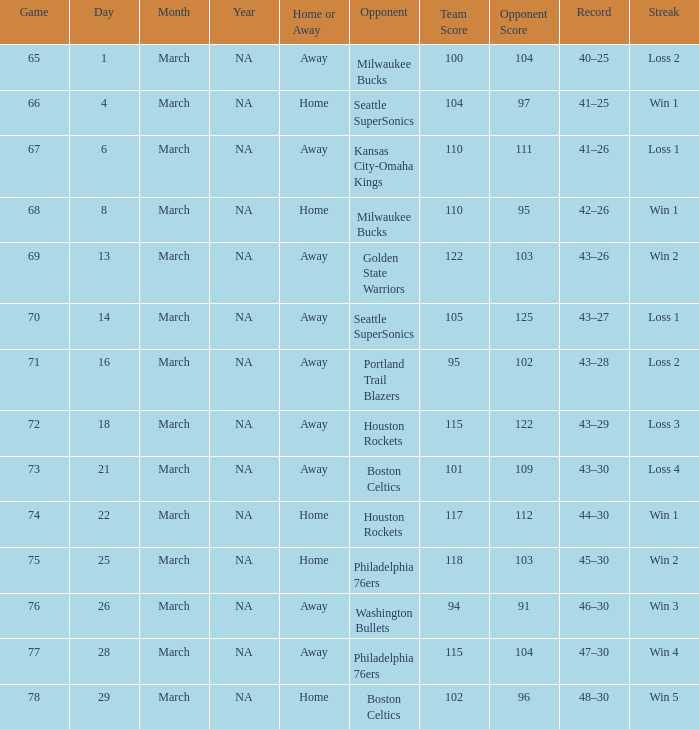What is Team, when Game is 77? @ Philadelphia 76ers. 